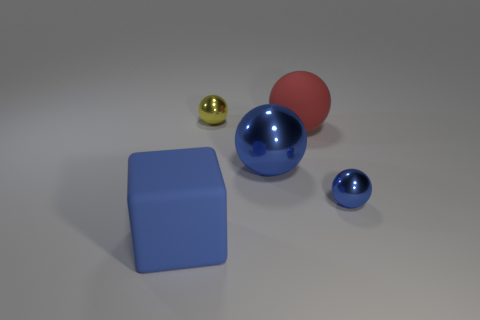How many objects are to the right of the large metal object?
Your answer should be compact. 2. Does the blue object left of the yellow object have the same size as the rubber thing on the right side of the blue rubber thing?
Your answer should be very brief. Yes. What number of other objects are the same size as the red ball?
Your answer should be compact. 2. The big thing that is on the right side of the big blue object right of the large rubber thing in front of the red object is made of what material?
Offer a terse response. Rubber. Is the size of the blue matte block the same as the matte thing right of the yellow shiny thing?
Offer a very short reply. Yes. How big is the sphere that is both behind the big blue metallic sphere and to the right of the yellow shiny sphere?
Your answer should be very brief. Large. Are there any rubber blocks of the same color as the big metal sphere?
Provide a short and direct response. Yes. The large rubber thing that is behind the big object that is left of the yellow thing is what color?
Offer a very short reply. Red. Is the number of tiny shiny balls that are behind the yellow shiny object less than the number of large balls that are behind the big metal sphere?
Provide a succinct answer. Yes. Is the yellow object the same size as the blue rubber object?
Ensure brevity in your answer.  No. 